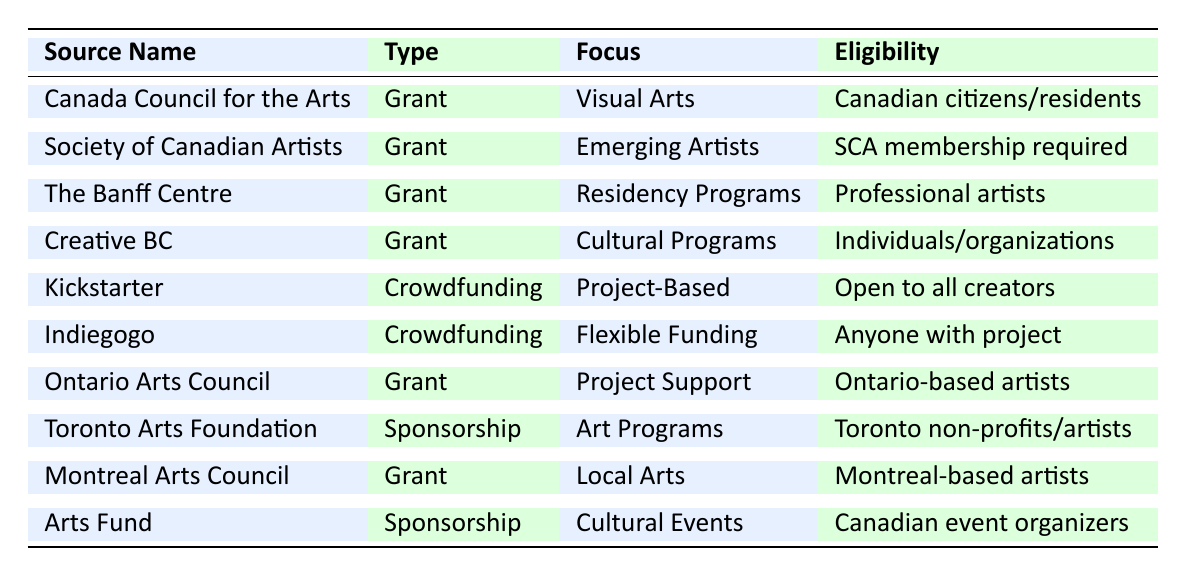What is the focus of the Canada Council for the Arts? The table specifies that the Canada Council for the Arts focuses on "Visual Arts".
Answer: Visual Arts How often can you apply for a grant from The Banff Centre? According to the table, application frequency for The Banff Centre is "Quarterly".
Answer: Quarterly Is the Society of Canadian Artists open to anyone who wants to apply for a grant? The table states that membership in the Society of Canadian Artists (SCA) is required for eligibility, so not just anyone can apply.
Answer: No How many sponsorship sources are listed in the table? There are two sponsorship sources mentioned: the Toronto Arts Foundation and the Arts Fund.
Answer: 2 Which funding source focuses on "Emerging Artists"? The table indicates that the Society of Canadian Artists (SCA) focuses on "Emerging Artists".
Answer: Society of Canadian Artists (SCA) What are the eligibility criteria for Kickstarter? The table states that Kickstarter is open to all creators with a project pitch.
Answer: Open to all creators Which funding source supports project-based funding? The table shows that Kickstarter supports "Project-Based Funding".
Answer: Kickstarter Are there any sources of funding that have annual application frequency? The table lists Canada Council for the Arts, Creative BC, Toronto Arts Foundation, and Montreal Arts Council all have an annual application frequency.
Answer: Yes Which type of funding source is focused on "Cultural Programs"? The focus on "Cultural Programs" is provided by Creative BC, which is categorized as a Grant.
Answer: Creative BC How does the application frequency of Ontario Arts Council compare to that of the Montreal Arts Council? Ontario Arts Council lists various frequencies (monthly, quarterly), while Montreal Arts Council has an annual frequency, so Ontario Arts Council has a more flexible application frequency.
Answer: More flexible What is the main focus of the Arts Fund? The table notes that the Arts Fund focuses on "Cultural Events".
Answer: Cultural Events 